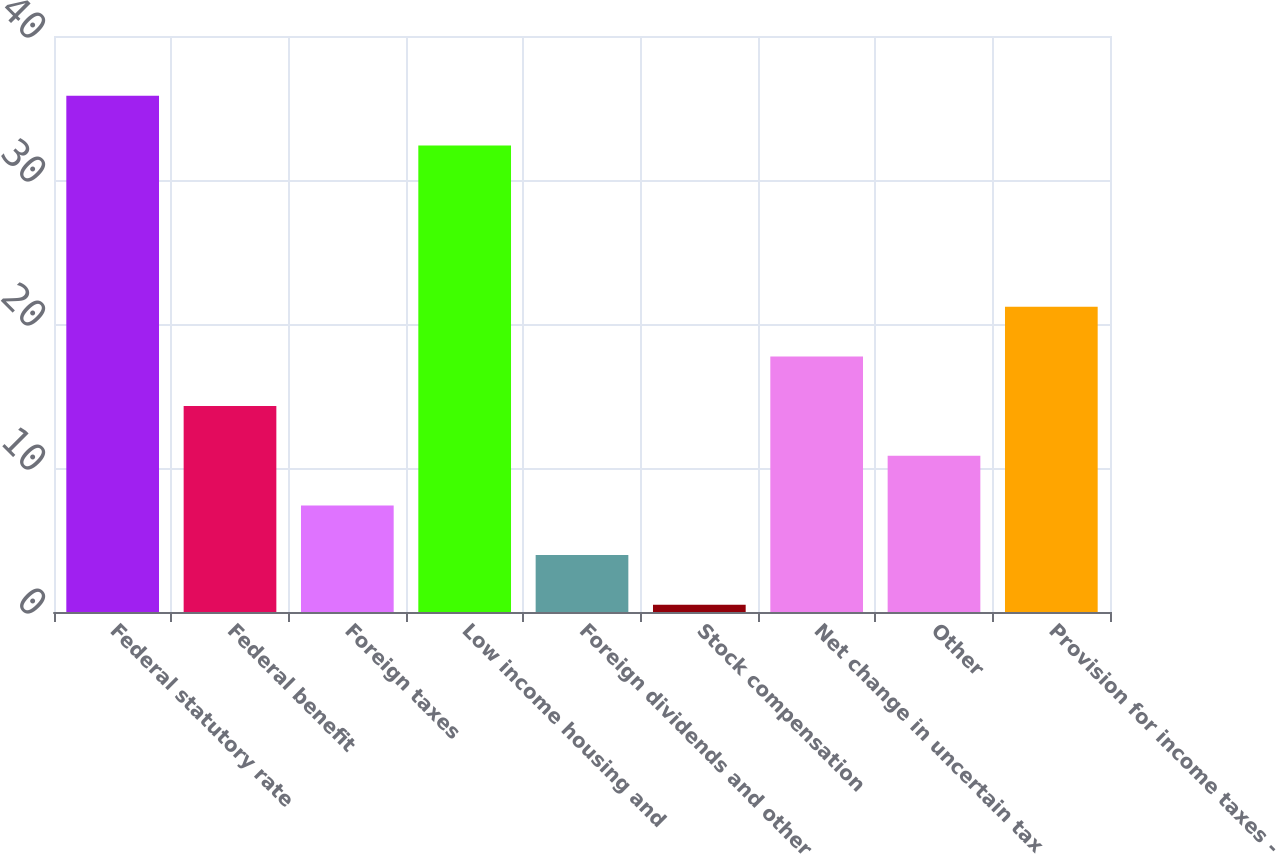Convert chart to OTSL. <chart><loc_0><loc_0><loc_500><loc_500><bar_chart><fcel>Federal statutory rate<fcel>Federal benefit<fcel>Foreign taxes<fcel>Low income housing and<fcel>Foreign dividends and other<fcel>Stock compensation<fcel>Net change in uncertain tax<fcel>Other<fcel>Provision for income taxes -<nl><fcel>35.85<fcel>14.3<fcel>7.4<fcel>32.4<fcel>3.95<fcel>0.5<fcel>17.75<fcel>10.85<fcel>21.2<nl></chart> 